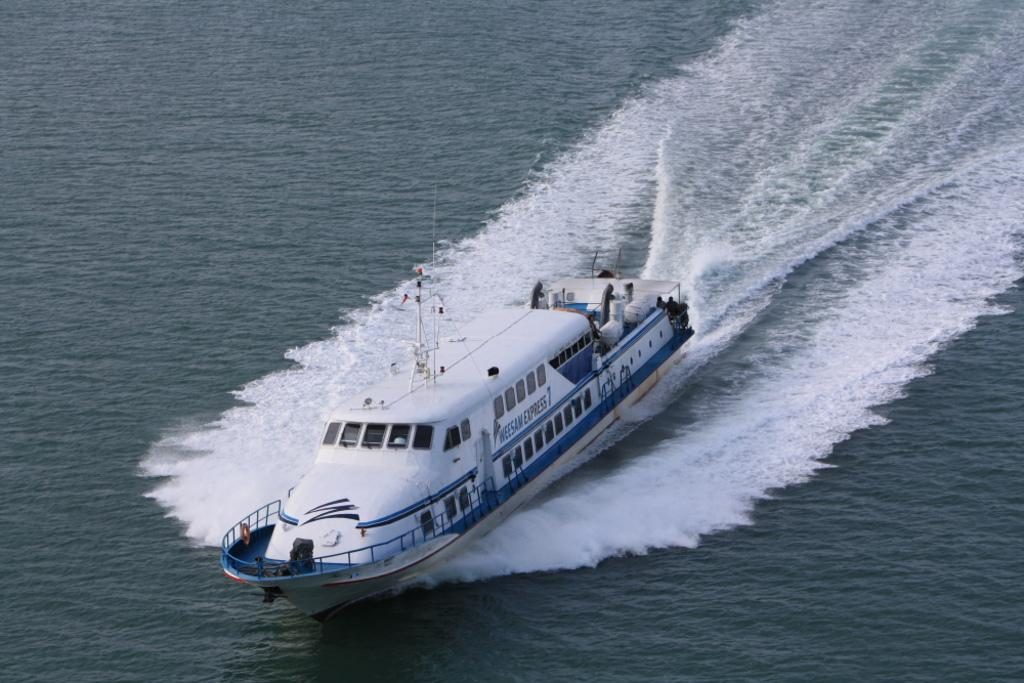What is the main subject of the image? The main subject of the image is a ship. Where is the ship located? The ship is on the water. What type of soda is being served on the ship in the image? There is no soda present in the image, as it only features a ship on the water. What is the angle of the ship in the image? The angle of the ship cannot be determined from the image, as it only shows the ship on the water without any perspective or orientation details. 